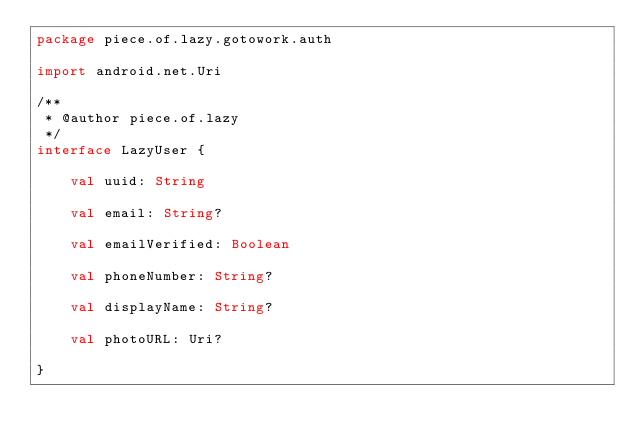<code> <loc_0><loc_0><loc_500><loc_500><_Kotlin_>package piece.of.lazy.gotowork.auth

import android.net.Uri

/**
 * @author piece.of.lazy
 */
interface LazyUser {

    val uuid: String

    val email: String?

    val emailVerified: Boolean

    val phoneNumber: String?

    val displayName: String?

    val photoURL: Uri?

}</code> 